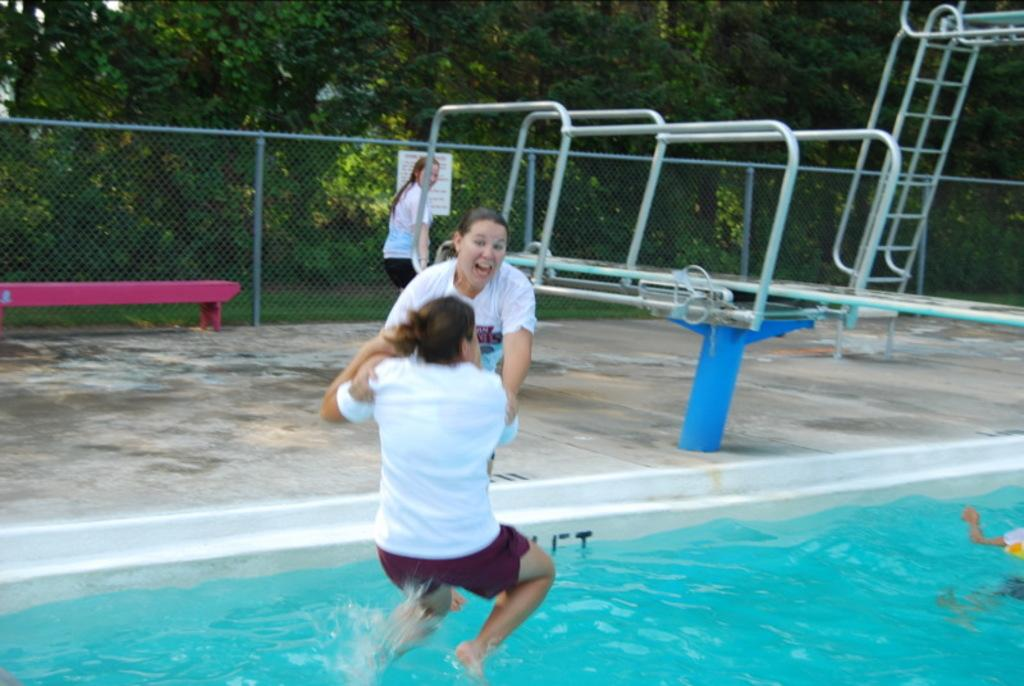Who can be seen in the image? There are people in the image, including a woman. What is the woman doing in the image? The woman is jumping into the water. What objects can be seen in the image besides the people? There are metal rods, a fence, and trees visible in the image. What type of owl can be seen perched on the fence in the image? There is no owl present in the image; it features people, metal rods, a fence, and trees. 